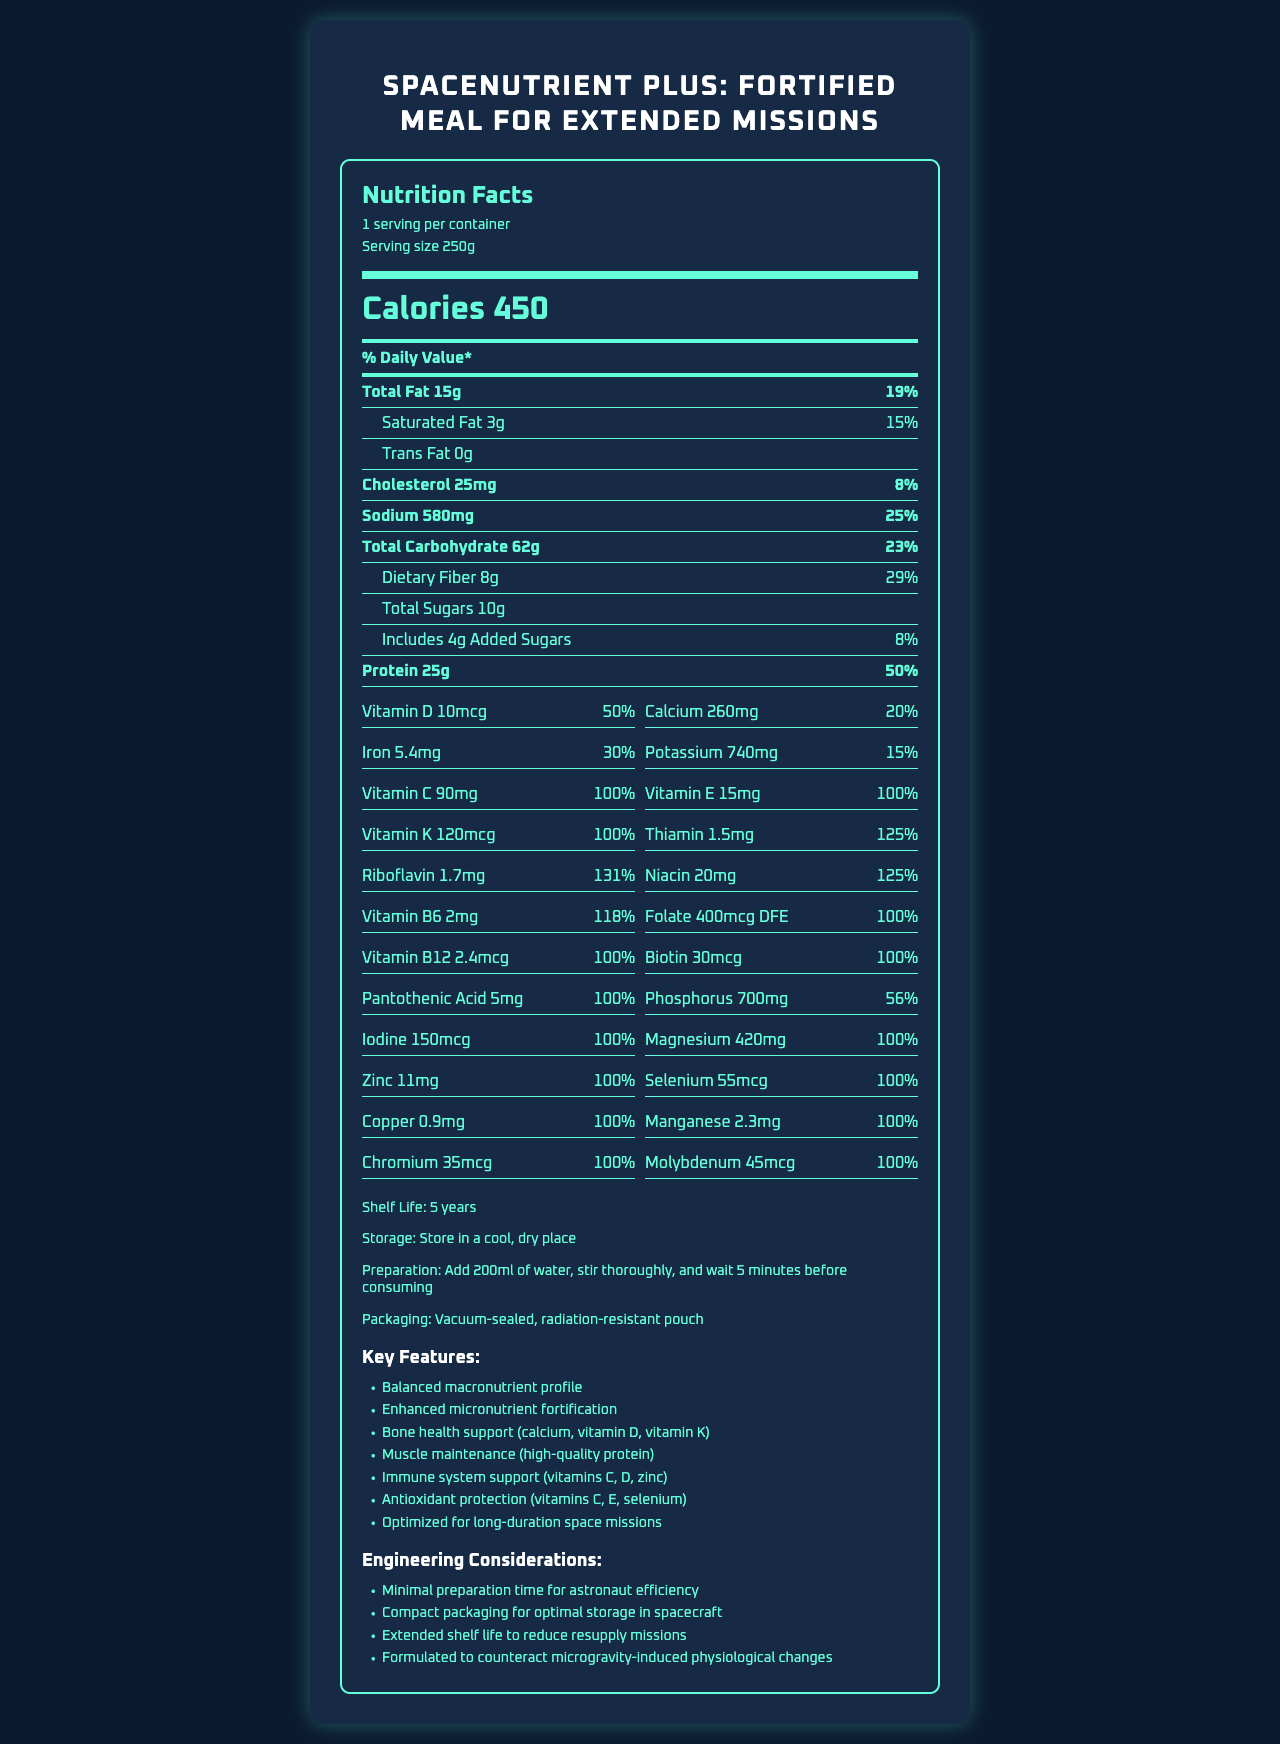what is the product name? The product name is clearly mentioned at the top of the document.
Answer: SpaceNutrient Plus: Fortified Meal for Extended Missions what is the serving size? The serving size is mentioned under the "serving info" section.
Answer: 250g how many servings per container are there? The servings per container is mentioned under the "serving info" section.
Answer: 1 how many calories are in one serving? The number of calories is mentioned in the "calories" section.
Answer: 450 what is the amount of dietary fiber per serving? The amount of dietary fiber is mentioned under the "Total Carbohydrate" section.
Answer: 8g how much protein does one serving provide? The amount of protein per serving is stated under the "Protein" section.
Answer: 25g what percentage of the daily value does vitamin D provide? The daily value percentage of vitamin D is mentioned under the "vitamin d" section in vitamins and minerals.
Answer: 50% how many grams of total fat are there per serving? The total grams of fat per serving are listed under the "Total Fat" section.
Answer: 15g how much sodium is in each serving? The amount of sodium per serving is mentioned under the "Sodium" section.
Answer: 580mg how much calcium is present in one serving? The amount of calcium is listed under the "Calcium" section in vitamins and minerals.
Answer: 260mg what vitamins and minerals are at 100% daily value or higher? A. Vitamin E, Thiamin, Magnesium B. Folate, Phosphorus, Iron C. Vitamin C, Riboflavin, Copper D. Niacin, Potassium, Iron Vitamins and minerals like Vitamin C, Riboflavin, Copper all have a daily value of 100% or higher as mentioned in the vitamins and minerals section.
Answer: C which feature is NOT part of the key features section? A. Balanced macronutrient profile B. Enhanced micronutrient fortification C. Engine Compatibility D. Muscle maintenance "Engine Compatibility" is not listed as a key feature in the additional info section.
Answer: C is this product optimized for long-duration space missions? The document states that the product is "Optimized for long-duration space missions" in the key features section.
Answer: Yes summarize the main considerations detailed in the document. The document summarizes the fortified meal's nutritional content and highlights factors like shelf life and ease of preparation, key for long-duration space missions.
Answer: The document provides detailed nutritional information for one serving of "SpaceNutrient Plus: Fortified Meal for Extended Missions" which includes calories, macronutrients, vitamins, and minerals. It also includes additional information about shelf life, storage conditions, preparation steps, packaging, key features, and engineering considerations. how long is the shelf life of this product? The shelf life is listed under the additional info section.
Answer: 5 years how much biotin does the product contain per serving? The amount of biotin is stated in the vitamins and minerals section.
Answer: 30mcg what is the main source of protein in this product? The document does not specify the source of the protein content.
Answer: Not enough information does this product contribute to bone health? Bone health support through calcium, vitamin D, and vitamin K is mentioned as a key feature in the additional info section.
Answer: Yes 